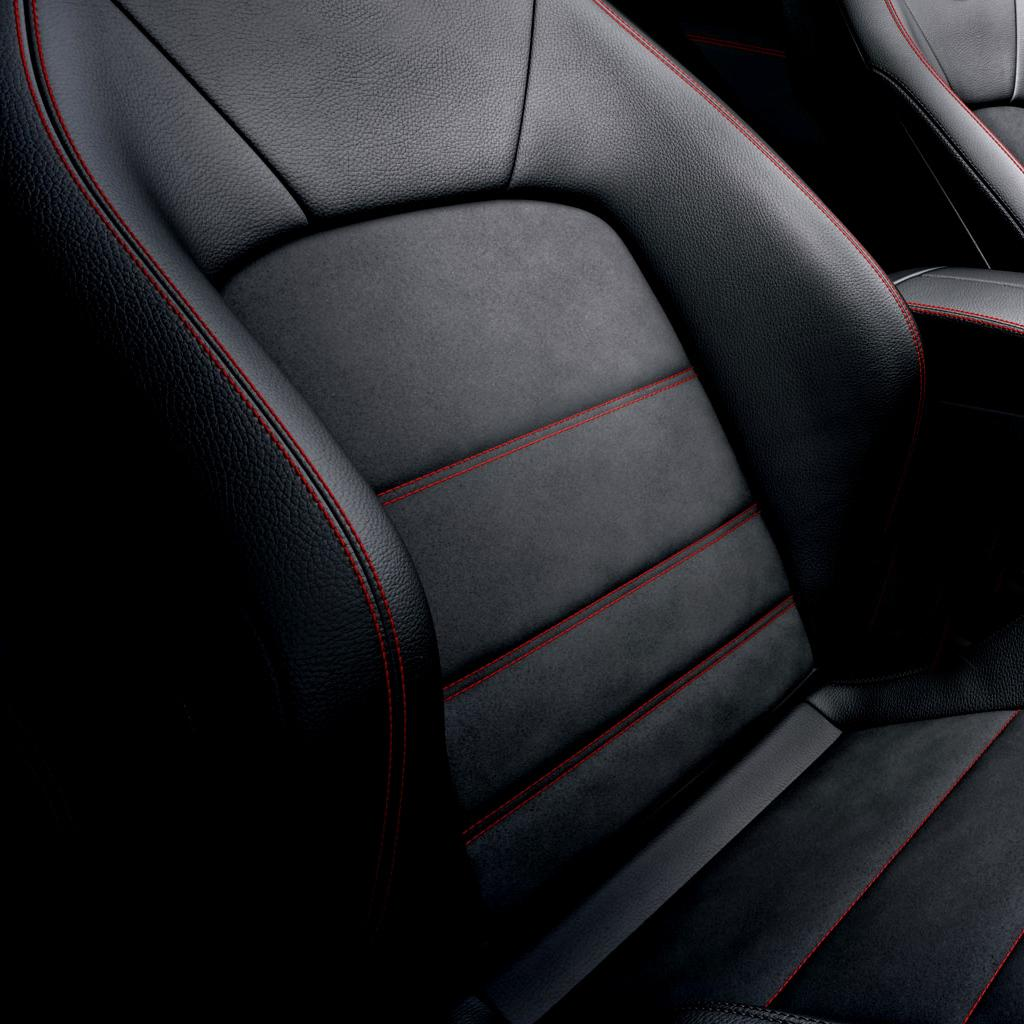What is the main subject of the image? The main subject of the image is the seat of a vehicle. What colors are used for the seat? The seat is in black and red color. What type of clouds can be seen in the image? There are no clouds present in the image, as it features a seat of a vehicle. What is the chin of the person sitting on the seat like? There is no person sitting on the seat in the image, so it is not possible to describe their chin. 